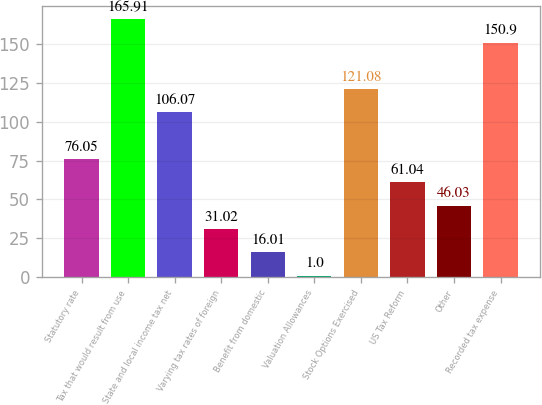<chart> <loc_0><loc_0><loc_500><loc_500><bar_chart><fcel>Statutory rate<fcel>Tax that would result from use<fcel>State and local income tax net<fcel>Varying tax rates of foreign<fcel>Benefit from domestic<fcel>Valuation Allowances<fcel>Stock Options Exercised<fcel>US Tax Reform<fcel>Other<fcel>Recorded tax expense<nl><fcel>76.05<fcel>165.91<fcel>106.07<fcel>31.02<fcel>16.01<fcel>1<fcel>121.08<fcel>61.04<fcel>46.03<fcel>150.9<nl></chart> 